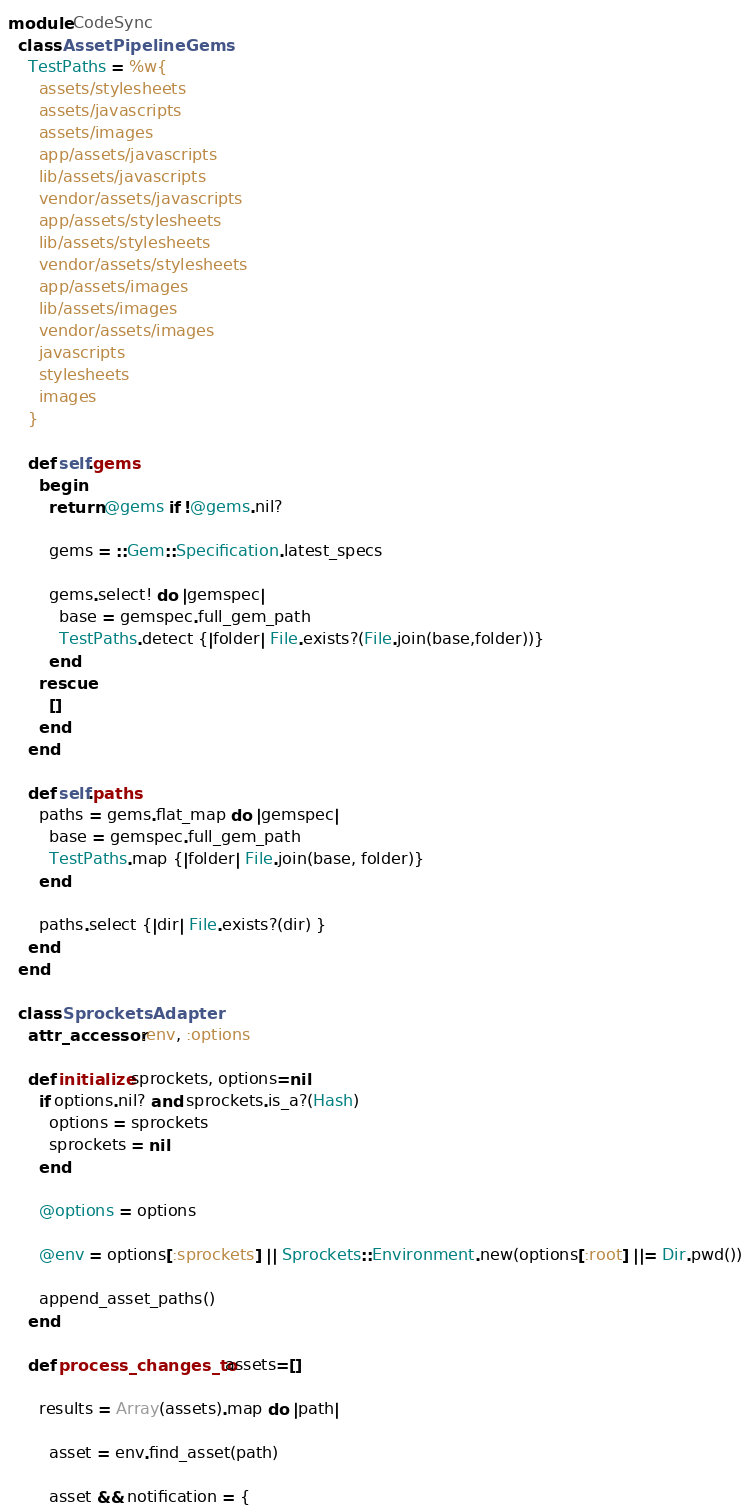Convert code to text. <code><loc_0><loc_0><loc_500><loc_500><_Ruby_>module CodeSync
  class AssetPipelineGems
    TestPaths = %w{
      assets/stylesheets
      assets/javascripts
      assets/images
      app/assets/javascripts
      lib/assets/javascripts
      vendor/assets/javascripts
      app/assets/stylesheets
      lib/assets/stylesheets
      vendor/assets/stylesheets
      app/assets/images
      lib/assets/images
      vendor/assets/images
      javascripts
      stylesheets
      images
    }

    def self.gems
      begin
        return @gems if !@gems.nil?

        gems = ::Gem::Specification.latest_specs

        gems.select! do |gemspec|
          base = gemspec.full_gem_path
          TestPaths.detect {|folder| File.exists?(File.join(base,folder))}
        end
      rescue
        []
      end
    end

    def self.paths
      paths = gems.flat_map do |gemspec|
        base = gemspec.full_gem_path
        TestPaths.map {|folder| File.join(base, folder)}
      end

      paths.select {|dir| File.exists?(dir) }
    end
  end

  class SprocketsAdapter
    attr_accessor :env, :options

    def initialize sprockets, options=nil
      if options.nil? and sprockets.is_a?(Hash)
        options = sprockets
        sprockets = nil
      end

      @options = options

      @env = options[:sprockets] || Sprockets::Environment.new(options[:root] ||= Dir.pwd())

      append_asset_paths()
    end

    def process_changes_to assets=[]

      results = Array(assets).map do |path|

        asset = env.find_asset(path)

        asset && notification = {</code> 